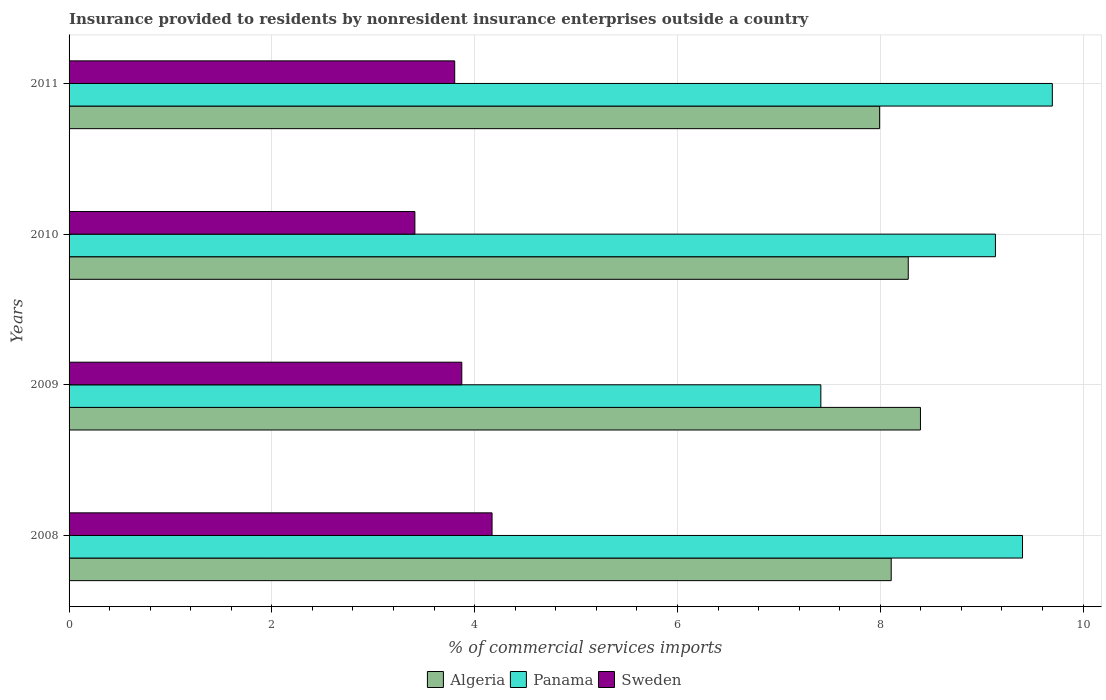How many groups of bars are there?
Your answer should be very brief. 4. Are the number of bars per tick equal to the number of legend labels?
Your answer should be very brief. Yes. How many bars are there on the 4th tick from the bottom?
Offer a very short reply. 3. In how many cases, is the number of bars for a given year not equal to the number of legend labels?
Offer a terse response. 0. What is the Insurance provided to residents in Algeria in 2011?
Ensure brevity in your answer.  7.99. Across all years, what is the maximum Insurance provided to residents in Sweden?
Offer a terse response. 4.17. Across all years, what is the minimum Insurance provided to residents in Panama?
Provide a short and direct response. 7.41. In which year was the Insurance provided to residents in Algeria minimum?
Your response must be concise. 2011. What is the total Insurance provided to residents in Panama in the graph?
Ensure brevity in your answer.  35.65. What is the difference between the Insurance provided to residents in Algeria in 2008 and that in 2011?
Provide a succinct answer. 0.11. What is the difference between the Insurance provided to residents in Algeria in 2010 and the Insurance provided to residents in Panama in 2008?
Ensure brevity in your answer.  -1.13. What is the average Insurance provided to residents in Panama per year?
Your answer should be compact. 8.91. In the year 2009, what is the difference between the Insurance provided to residents in Sweden and Insurance provided to residents in Panama?
Make the answer very short. -3.54. What is the ratio of the Insurance provided to residents in Panama in 2009 to that in 2011?
Offer a very short reply. 0.76. Is the Insurance provided to residents in Algeria in 2008 less than that in 2011?
Provide a short and direct response. No. Is the difference between the Insurance provided to residents in Sweden in 2009 and 2011 greater than the difference between the Insurance provided to residents in Panama in 2009 and 2011?
Ensure brevity in your answer.  Yes. What is the difference between the highest and the second highest Insurance provided to residents in Algeria?
Your answer should be compact. 0.12. What is the difference between the highest and the lowest Insurance provided to residents in Panama?
Offer a very short reply. 2.28. In how many years, is the Insurance provided to residents in Algeria greater than the average Insurance provided to residents in Algeria taken over all years?
Keep it short and to the point. 2. What does the 1st bar from the bottom in 2011 represents?
Offer a terse response. Algeria. How many bars are there?
Your answer should be very brief. 12. What is the difference between two consecutive major ticks on the X-axis?
Your answer should be compact. 2. What is the title of the graph?
Offer a terse response. Insurance provided to residents by nonresident insurance enterprises outside a country. What is the label or title of the X-axis?
Ensure brevity in your answer.  % of commercial services imports. What is the % of commercial services imports of Algeria in 2008?
Keep it short and to the point. 8.11. What is the % of commercial services imports of Panama in 2008?
Provide a succinct answer. 9.4. What is the % of commercial services imports in Sweden in 2008?
Provide a succinct answer. 4.17. What is the % of commercial services imports of Algeria in 2009?
Your answer should be compact. 8.4. What is the % of commercial services imports in Panama in 2009?
Offer a terse response. 7.41. What is the % of commercial services imports of Sweden in 2009?
Offer a terse response. 3.87. What is the % of commercial services imports in Algeria in 2010?
Provide a short and direct response. 8.28. What is the % of commercial services imports of Panama in 2010?
Provide a succinct answer. 9.14. What is the % of commercial services imports in Sweden in 2010?
Offer a terse response. 3.41. What is the % of commercial services imports in Algeria in 2011?
Give a very brief answer. 7.99. What is the % of commercial services imports of Panama in 2011?
Ensure brevity in your answer.  9.7. What is the % of commercial services imports in Sweden in 2011?
Offer a very short reply. 3.8. Across all years, what is the maximum % of commercial services imports of Algeria?
Offer a very short reply. 8.4. Across all years, what is the maximum % of commercial services imports of Panama?
Your answer should be very brief. 9.7. Across all years, what is the maximum % of commercial services imports in Sweden?
Your response must be concise. 4.17. Across all years, what is the minimum % of commercial services imports in Algeria?
Your answer should be compact. 7.99. Across all years, what is the minimum % of commercial services imports of Panama?
Keep it short and to the point. 7.41. Across all years, what is the minimum % of commercial services imports of Sweden?
Provide a short and direct response. 3.41. What is the total % of commercial services imports in Algeria in the graph?
Make the answer very short. 32.77. What is the total % of commercial services imports of Panama in the graph?
Ensure brevity in your answer.  35.65. What is the total % of commercial services imports in Sweden in the graph?
Ensure brevity in your answer.  15.26. What is the difference between the % of commercial services imports in Algeria in 2008 and that in 2009?
Keep it short and to the point. -0.29. What is the difference between the % of commercial services imports of Panama in 2008 and that in 2009?
Offer a very short reply. 1.99. What is the difference between the % of commercial services imports of Sweden in 2008 and that in 2009?
Offer a terse response. 0.3. What is the difference between the % of commercial services imports of Algeria in 2008 and that in 2010?
Your answer should be compact. -0.17. What is the difference between the % of commercial services imports of Panama in 2008 and that in 2010?
Provide a short and direct response. 0.27. What is the difference between the % of commercial services imports of Sweden in 2008 and that in 2010?
Make the answer very short. 0.76. What is the difference between the % of commercial services imports in Algeria in 2008 and that in 2011?
Provide a short and direct response. 0.11. What is the difference between the % of commercial services imports of Panama in 2008 and that in 2011?
Make the answer very short. -0.29. What is the difference between the % of commercial services imports of Sweden in 2008 and that in 2011?
Ensure brevity in your answer.  0.37. What is the difference between the % of commercial services imports in Algeria in 2009 and that in 2010?
Your response must be concise. 0.12. What is the difference between the % of commercial services imports in Panama in 2009 and that in 2010?
Your response must be concise. -1.72. What is the difference between the % of commercial services imports in Sweden in 2009 and that in 2010?
Provide a short and direct response. 0.46. What is the difference between the % of commercial services imports of Algeria in 2009 and that in 2011?
Give a very brief answer. 0.4. What is the difference between the % of commercial services imports of Panama in 2009 and that in 2011?
Give a very brief answer. -2.28. What is the difference between the % of commercial services imports in Sweden in 2009 and that in 2011?
Provide a short and direct response. 0.07. What is the difference between the % of commercial services imports of Algeria in 2010 and that in 2011?
Your answer should be compact. 0.28. What is the difference between the % of commercial services imports in Panama in 2010 and that in 2011?
Provide a succinct answer. -0.56. What is the difference between the % of commercial services imports in Sweden in 2010 and that in 2011?
Provide a short and direct response. -0.39. What is the difference between the % of commercial services imports in Algeria in 2008 and the % of commercial services imports in Panama in 2009?
Provide a short and direct response. 0.69. What is the difference between the % of commercial services imports of Algeria in 2008 and the % of commercial services imports of Sweden in 2009?
Ensure brevity in your answer.  4.24. What is the difference between the % of commercial services imports in Panama in 2008 and the % of commercial services imports in Sweden in 2009?
Your answer should be very brief. 5.53. What is the difference between the % of commercial services imports in Algeria in 2008 and the % of commercial services imports in Panama in 2010?
Your answer should be compact. -1.03. What is the difference between the % of commercial services imports of Algeria in 2008 and the % of commercial services imports of Sweden in 2010?
Provide a succinct answer. 4.7. What is the difference between the % of commercial services imports of Panama in 2008 and the % of commercial services imports of Sweden in 2010?
Your answer should be compact. 5.99. What is the difference between the % of commercial services imports of Algeria in 2008 and the % of commercial services imports of Panama in 2011?
Your response must be concise. -1.59. What is the difference between the % of commercial services imports in Algeria in 2008 and the % of commercial services imports in Sweden in 2011?
Make the answer very short. 4.3. What is the difference between the % of commercial services imports of Panama in 2008 and the % of commercial services imports of Sweden in 2011?
Provide a succinct answer. 5.6. What is the difference between the % of commercial services imports of Algeria in 2009 and the % of commercial services imports of Panama in 2010?
Keep it short and to the point. -0.74. What is the difference between the % of commercial services imports of Algeria in 2009 and the % of commercial services imports of Sweden in 2010?
Offer a very short reply. 4.99. What is the difference between the % of commercial services imports of Panama in 2009 and the % of commercial services imports of Sweden in 2010?
Your response must be concise. 4. What is the difference between the % of commercial services imports in Algeria in 2009 and the % of commercial services imports in Panama in 2011?
Ensure brevity in your answer.  -1.3. What is the difference between the % of commercial services imports of Algeria in 2009 and the % of commercial services imports of Sweden in 2011?
Give a very brief answer. 4.59. What is the difference between the % of commercial services imports of Panama in 2009 and the % of commercial services imports of Sweden in 2011?
Offer a terse response. 3.61. What is the difference between the % of commercial services imports in Algeria in 2010 and the % of commercial services imports in Panama in 2011?
Make the answer very short. -1.42. What is the difference between the % of commercial services imports of Algeria in 2010 and the % of commercial services imports of Sweden in 2011?
Keep it short and to the point. 4.47. What is the difference between the % of commercial services imports of Panama in 2010 and the % of commercial services imports of Sweden in 2011?
Make the answer very short. 5.33. What is the average % of commercial services imports in Algeria per year?
Ensure brevity in your answer.  8.19. What is the average % of commercial services imports of Panama per year?
Provide a short and direct response. 8.91. What is the average % of commercial services imports in Sweden per year?
Offer a very short reply. 3.81. In the year 2008, what is the difference between the % of commercial services imports in Algeria and % of commercial services imports in Panama?
Provide a succinct answer. -1.29. In the year 2008, what is the difference between the % of commercial services imports in Algeria and % of commercial services imports in Sweden?
Provide a succinct answer. 3.94. In the year 2008, what is the difference between the % of commercial services imports of Panama and % of commercial services imports of Sweden?
Keep it short and to the point. 5.23. In the year 2009, what is the difference between the % of commercial services imports of Algeria and % of commercial services imports of Panama?
Keep it short and to the point. 0.98. In the year 2009, what is the difference between the % of commercial services imports of Algeria and % of commercial services imports of Sweden?
Your answer should be very brief. 4.52. In the year 2009, what is the difference between the % of commercial services imports of Panama and % of commercial services imports of Sweden?
Keep it short and to the point. 3.54. In the year 2010, what is the difference between the % of commercial services imports in Algeria and % of commercial services imports in Panama?
Your answer should be compact. -0.86. In the year 2010, what is the difference between the % of commercial services imports in Algeria and % of commercial services imports in Sweden?
Offer a terse response. 4.87. In the year 2010, what is the difference between the % of commercial services imports of Panama and % of commercial services imports of Sweden?
Keep it short and to the point. 5.73. In the year 2011, what is the difference between the % of commercial services imports of Algeria and % of commercial services imports of Panama?
Provide a succinct answer. -1.7. In the year 2011, what is the difference between the % of commercial services imports of Algeria and % of commercial services imports of Sweden?
Give a very brief answer. 4.19. In the year 2011, what is the difference between the % of commercial services imports in Panama and % of commercial services imports in Sweden?
Your answer should be compact. 5.89. What is the ratio of the % of commercial services imports of Algeria in 2008 to that in 2009?
Your answer should be very brief. 0.97. What is the ratio of the % of commercial services imports of Panama in 2008 to that in 2009?
Your answer should be compact. 1.27. What is the ratio of the % of commercial services imports of Sweden in 2008 to that in 2009?
Ensure brevity in your answer.  1.08. What is the ratio of the % of commercial services imports in Algeria in 2008 to that in 2010?
Provide a succinct answer. 0.98. What is the ratio of the % of commercial services imports of Panama in 2008 to that in 2010?
Your answer should be very brief. 1.03. What is the ratio of the % of commercial services imports in Sweden in 2008 to that in 2010?
Keep it short and to the point. 1.22. What is the ratio of the % of commercial services imports of Algeria in 2008 to that in 2011?
Offer a terse response. 1.01. What is the ratio of the % of commercial services imports in Panama in 2008 to that in 2011?
Provide a short and direct response. 0.97. What is the ratio of the % of commercial services imports of Sweden in 2008 to that in 2011?
Keep it short and to the point. 1.1. What is the ratio of the % of commercial services imports of Algeria in 2009 to that in 2010?
Make the answer very short. 1.01. What is the ratio of the % of commercial services imports of Panama in 2009 to that in 2010?
Give a very brief answer. 0.81. What is the ratio of the % of commercial services imports of Sweden in 2009 to that in 2010?
Give a very brief answer. 1.14. What is the ratio of the % of commercial services imports of Algeria in 2009 to that in 2011?
Your answer should be very brief. 1.05. What is the ratio of the % of commercial services imports in Panama in 2009 to that in 2011?
Your answer should be compact. 0.76. What is the ratio of the % of commercial services imports of Sweden in 2009 to that in 2011?
Your answer should be compact. 1.02. What is the ratio of the % of commercial services imports in Algeria in 2010 to that in 2011?
Keep it short and to the point. 1.04. What is the ratio of the % of commercial services imports in Panama in 2010 to that in 2011?
Your response must be concise. 0.94. What is the ratio of the % of commercial services imports of Sweden in 2010 to that in 2011?
Offer a terse response. 0.9. What is the difference between the highest and the second highest % of commercial services imports in Algeria?
Provide a short and direct response. 0.12. What is the difference between the highest and the second highest % of commercial services imports in Panama?
Your response must be concise. 0.29. What is the difference between the highest and the second highest % of commercial services imports in Sweden?
Provide a succinct answer. 0.3. What is the difference between the highest and the lowest % of commercial services imports of Algeria?
Provide a succinct answer. 0.4. What is the difference between the highest and the lowest % of commercial services imports in Panama?
Provide a short and direct response. 2.28. What is the difference between the highest and the lowest % of commercial services imports in Sweden?
Your response must be concise. 0.76. 